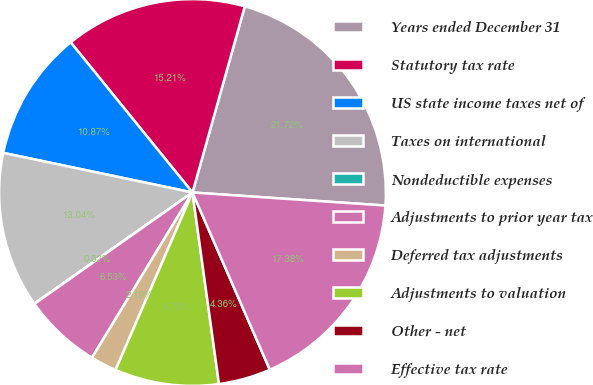Convert chart. <chart><loc_0><loc_0><loc_500><loc_500><pie_chart><fcel>Years ended December 31<fcel>Statutory tax rate<fcel>US state income taxes net of<fcel>Taxes on international<fcel>Nondeductible expenses<fcel>Adjustments to prior year tax<fcel>Deferred tax adjustments<fcel>Adjustments to valuation<fcel>Other - net<fcel>Effective tax rate<nl><fcel>21.72%<fcel>15.21%<fcel>10.87%<fcel>13.04%<fcel>0.02%<fcel>6.53%<fcel>2.19%<fcel>8.7%<fcel>4.36%<fcel>17.38%<nl></chart> 